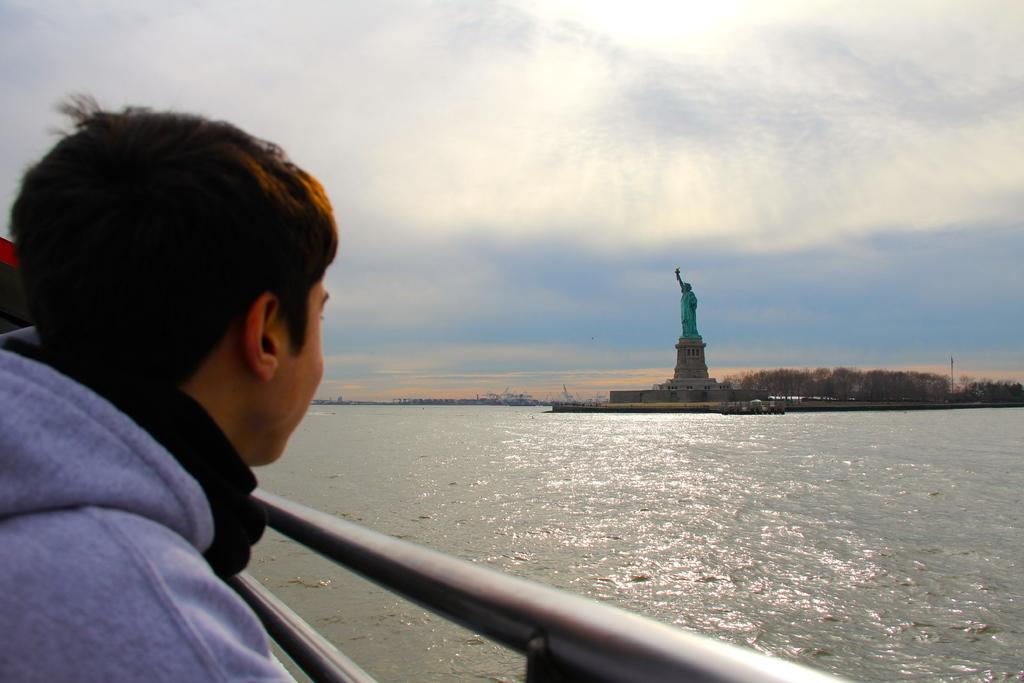What is the main subject of the image? There is a man standing in the image. What is the primary feature of the environment in the image? There is a significant amount of water in the image. What other object can be seen in the image? There is a statue in the image. What type of natural scenery is visible in the background of the image? There are trees in the background of the image. What is visible at the top of the image? The sky is visible at the top of the image. What type of music can be heard coming from the statue in the image? There is no indication in the image that the statue is producing music, so it cannot be determined from the picture. 